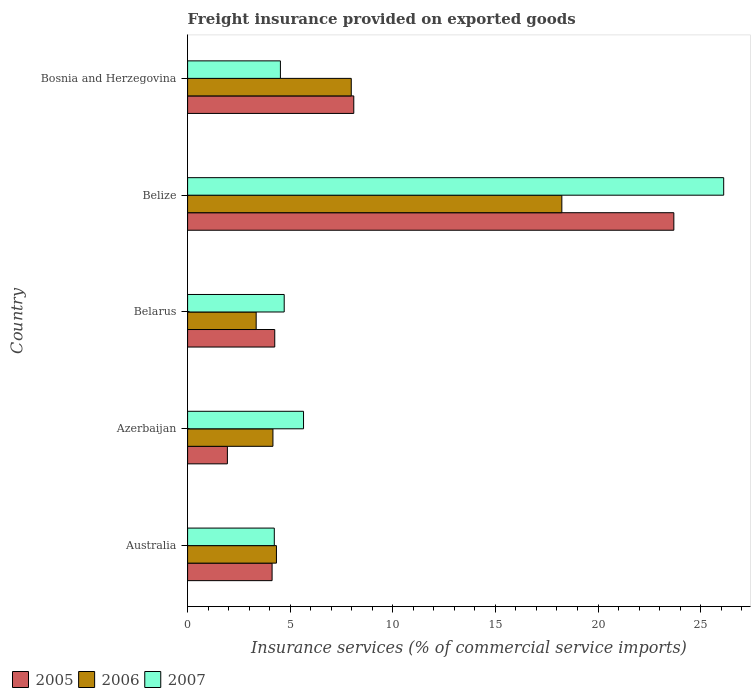How many groups of bars are there?
Your answer should be compact. 5. Are the number of bars on each tick of the Y-axis equal?
Provide a short and direct response. Yes. How many bars are there on the 1st tick from the bottom?
Your response must be concise. 3. What is the label of the 1st group of bars from the top?
Your response must be concise. Bosnia and Herzegovina. In how many cases, is the number of bars for a given country not equal to the number of legend labels?
Your answer should be very brief. 0. What is the freight insurance provided on exported goods in 2005 in Azerbaijan?
Provide a succinct answer. 1.94. Across all countries, what is the maximum freight insurance provided on exported goods in 2005?
Offer a very short reply. 23.7. Across all countries, what is the minimum freight insurance provided on exported goods in 2005?
Offer a very short reply. 1.94. In which country was the freight insurance provided on exported goods in 2005 maximum?
Your answer should be compact. Belize. What is the total freight insurance provided on exported goods in 2007 in the graph?
Your response must be concise. 45.23. What is the difference between the freight insurance provided on exported goods in 2006 in Australia and that in Belize?
Make the answer very short. -13.91. What is the difference between the freight insurance provided on exported goods in 2007 in Belize and the freight insurance provided on exported goods in 2006 in Australia?
Ensure brevity in your answer.  21.8. What is the average freight insurance provided on exported goods in 2007 per country?
Offer a terse response. 9.05. What is the difference between the freight insurance provided on exported goods in 2005 and freight insurance provided on exported goods in 2006 in Azerbaijan?
Offer a terse response. -2.22. What is the ratio of the freight insurance provided on exported goods in 2006 in Australia to that in Belize?
Your response must be concise. 0.24. Is the freight insurance provided on exported goods in 2007 in Azerbaijan less than that in Belarus?
Keep it short and to the point. No. Is the difference between the freight insurance provided on exported goods in 2005 in Australia and Azerbaijan greater than the difference between the freight insurance provided on exported goods in 2006 in Australia and Azerbaijan?
Offer a terse response. Yes. What is the difference between the highest and the second highest freight insurance provided on exported goods in 2006?
Give a very brief answer. 10.26. What is the difference between the highest and the lowest freight insurance provided on exported goods in 2006?
Your answer should be compact. 14.9. In how many countries, is the freight insurance provided on exported goods in 2006 greater than the average freight insurance provided on exported goods in 2006 taken over all countries?
Give a very brief answer. 2. How many bars are there?
Provide a short and direct response. 15. Are all the bars in the graph horizontal?
Make the answer very short. Yes. How many countries are there in the graph?
Provide a succinct answer. 5. How many legend labels are there?
Your answer should be very brief. 3. What is the title of the graph?
Provide a succinct answer. Freight insurance provided on exported goods. What is the label or title of the X-axis?
Your response must be concise. Insurance services (% of commercial service imports). What is the label or title of the Y-axis?
Provide a short and direct response. Country. What is the Insurance services (% of commercial service imports) of 2005 in Australia?
Give a very brief answer. 4.12. What is the Insurance services (% of commercial service imports) in 2006 in Australia?
Give a very brief answer. 4.33. What is the Insurance services (% of commercial service imports) of 2007 in Australia?
Keep it short and to the point. 4.23. What is the Insurance services (% of commercial service imports) in 2005 in Azerbaijan?
Provide a short and direct response. 1.94. What is the Insurance services (% of commercial service imports) in 2006 in Azerbaijan?
Your answer should be compact. 4.16. What is the Insurance services (% of commercial service imports) in 2007 in Azerbaijan?
Offer a very short reply. 5.65. What is the Insurance services (% of commercial service imports) in 2005 in Belarus?
Keep it short and to the point. 4.25. What is the Insurance services (% of commercial service imports) in 2006 in Belarus?
Make the answer very short. 3.34. What is the Insurance services (% of commercial service imports) in 2007 in Belarus?
Your answer should be very brief. 4.71. What is the Insurance services (% of commercial service imports) in 2005 in Belize?
Your answer should be compact. 23.7. What is the Insurance services (% of commercial service imports) in 2006 in Belize?
Provide a succinct answer. 18.24. What is the Insurance services (% of commercial service imports) of 2007 in Belize?
Your response must be concise. 26.13. What is the Insurance services (% of commercial service imports) in 2005 in Bosnia and Herzegovina?
Your answer should be compact. 8.1. What is the Insurance services (% of commercial service imports) of 2006 in Bosnia and Herzegovina?
Provide a succinct answer. 7.98. What is the Insurance services (% of commercial service imports) of 2007 in Bosnia and Herzegovina?
Keep it short and to the point. 4.52. Across all countries, what is the maximum Insurance services (% of commercial service imports) in 2005?
Offer a terse response. 23.7. Across all countries, what is the maximum Insurance services (% of commercial service imports) of 2006?
Ensure brevity in your answer.  18.24. Across all countries, what is the maximum Insurance services (% of commercial service imports) in 2007?
Offer a very short reply. 26.13. Across all countries, what is the minimum Insurance services (% of commercial service imports) in 2005?
Give a very brief answer. 1.94. Across all countries, what is the minimum Insurance services (% of commercial service imports) in 2006?
Your answer should be compact. 3.34. Across all countries, what is the minimum Insurance services (% of commercial service imports) in 2007?
Keep it short and to the point. 4.23. What is the total Insurance services (% of commercial service imports) of 2005 in the graph?
Ensure brevity in your answer.  42.1. What is the total Insurance services (% of commercial service imports) in 2006 in the graph?
Offer a terse response. 38.04. What is the total Insurance services (% of commercial service imports) of 2007 in the graph?
Keep it short and to the point. 45.23. What is the difference between the Insurance services (% of commercial service imports) of 2005 in Australia and that in Azerbaijan?
Your answer should be compact. 2.18. What is the difference between the Insurance services (% of commercial service imports) in 2006 in Australia and that in Azerbaijan?
Offer a terse response. 0.17. What is the difference between the Insurance services (% of commercial service imports) of 2007 in Australia and that in Azerbaijan?
Ensure brevity in your answer.  -1.42. What is the difference between the Insurance services (% of commercial service imports) of 2005 in Australia and that in Belarus?
Your answer should be very brief. -0.13. What is the difference between the Insurance services (% of commercial service imports) of 2006 in Australia and that in Belarus?
Give a very brief answer. 0.99. What is the difference between the Insurance services (% of commercial service imports) of 2007 in Australia and that in Belarus?
Make the answer very short. -0.48. What is the difference between the Insurance services (% of commercial service imports) of 2005 in Australia and that in Belize?
Your response must be concise. -19.58. What is the difference between the Insurance services (% of commercial service imports) of 2006 in Australia and that in Belize?
Give a very brief answer. -13.91. What is the difference between the Insurance services (% of commercial service imports) of 2007 in Australia and that in Belize?
Your answer should be very brief. -21.9. What is the difference between the Insurance services (% of commercial service imports) of 2005 in Australia and that in Bosnia and Herzegovina?
Ensure brevity in your answer.  -3.98. What is the difference between the Insurance services (% of commercial service imports) of 2006 in Australia and that in Bosnia and Herzegovina?
Your response must be concise. -3.65. What is the difference between the Insurance services (% of commercial service imports) of 2007 in Australia and that in Bosnia and Herzegovina?
Provide a succinct answer. -0.3. What is the difference between the Insurance services (% of commercial service imports) in 2005 in Azerbaijan and that in Belarus?
Offer a terse response. -2.31. What is the difference between the Insurance services (% of commercial service imports) in 2006 in Azerbaijan and that in Belarus?
Provide a short and direct response. 0.82. What is the difference between the Insurance services (% of commercial service imports) of 2007 in Azerbaijan and that in Belarus?
Offer a terse response. 0.94. What is the difference between the Insurance services (% of commercial service imports) in 2005 in Azerbaijan and that in Belize?
Offer a very short reply. -21.76. What is the difference between the Insurance services (% of commercial service imports) in 2006 in Azerbaijan and that in Belize?
Provide a succinct answer. -14.08. What is the difference between the Insurance services (% of commercial service imports) of 2007 in Azerbaijan and that in Belize?
Your answer should be compact. -20.47. What is the difference between the Insurance services (% of commercial service imports) of 2005 in Azerbaijan and that in Bosnia and Herzegovina?
Offer a very short reply. -6.16. What is the difference between the Insurance services (% of commercial service imports) of 2006 in Azerbaijan and that in Bosnia and Herzegovina?
Provide a succinct answer. -3.82. What is the difference between the Insurance services (% of commercial service imports) in 2007 in Azerbaijan and that in Bosnia and Herzegovina?
Make the answer very short. 1.13. What is the difference between the Insurance services (% of commercial service imports) of 2005 in Belarus and that in Belize?
Ensure brevity in your answer.  -19.45. What is the difference between the Insurance services (% of commercial service imports) in 2006 in Belarus and that in Belize?
Offer a very short reply. -14.9. What is the difference between the Insurance services (% of commercial service imports) of 2007 in Belarus and that in Belize?
Give a very brief answer. -21.42. What is the difference between the Insurance services (% of commercial service imports) in 2005 in Belarus and that in Bosnia and Herzegovina?
Your answer should be compact. -3.85. What is the difference between the Insurance services (% of commercial service imports) of 2006 in Belarus and that in Bosnia and Herzegovina?
Your response must be concise. -4.63. What is the difference between the Insurance services (% of commercial service imports) of 2007 in Belarus and that in Bosnia and Herzegovina?
Provide a succinct answer. 0.18. What is the difference between the Insurance services (% of commercial service imports) of 2005 in Belize and that in Bosnia and Herzegovina?
Provide a succinct answer. 15.6. What is the difference between the Insurance services (% of commercial service imports) in 2006 in Belize and that in Bosnia and Herzegovina?
Your response must be concise. 10.26. What is the difference between the Insurance services (% of commercial service imports) of 2007 in Belize and that in Bosnia and Herzegovina?
Provide a succinct answer. 21.6. What is the difference between the Insurance services (% of commercial service imports) of 2005 in Australia and the Insurance services (% of commercial service imports) of 2006 in Azerbaijan?
Your answer should be compact. -0.04. What is the difference between the Insurance services (% of commercial service imports) of 2005 in Australia and the Insurance services (% of commercial service imports) of 2007 in Azerbaijan?
Keep it short and to the point. -1.53. What is the difference between the Insurance services (% of commercial service imports) of 2006 in Australia and the Insurance services (% of commercial service imports) of 2007 in Azerbaijan?
Keep it short and to the point. -1.32. What is the difference between the Insurance services (% of commercial service imports) in 2005 in Australia and the Insurance services (% of commercial service imports) in 2006 in Belarus?
Provide a short and direct response. 0.78. What is the difference between the Insurance services (% of commercial service imports) in 2005 in Australia and the Insurance services (% of commercial service imports) in 2007 in Belarus?
Offer a very short reply. -0.59. What is the difference between the Insurance services (% of commercial service imports) in 2006 in Australia and the Insurance services (% of commercial service imports) in 2007 in Belarus?
Provide a succinct answer. -0.38. What is the difference between the Insurance services (% of commercial service imports) of 2005 in Australia and the Insurance services (% of commercial service imports) of 2006 in Belize?
Provide a succinct answer. -14.12. What is the difference between the Insurance services (% of commercial service imports) in 2005 in Australia and the Insurance services (% of commercial service imports) in 2007 in Belize?
Provide a succinct answer. -22.01. What is the difference between the Insurance services (% of commercial service imports) in 2006 in Australia and the Insurance services (% of commercial service imports) in 2007 in Belize?
Offer a terse response. -21.8. What is the difference between the Insurance services (% of commercial service imports) in 2005 in Australia and the Insurance services (% of commercial service imports) in 2006 in Bosnia and Herzegovina?
Provide a short and direct response. -3.86. What is the difference between the Insurance services (% of commercial service imports) in 2005 in Australia and the Insurance services (% of commercial service imports) in 2007 in Bosnia and Herzegovina?
Offer a terse response. -0.41. What is the difference between the Insurance services (% of commercial service imports) of 2006 in Australia and the Insurance services (% of commercial service imports) of 2007 in Bosnia and Herzegovina?
Provide a succinct answer. -0.19. What is the difference between the Insurance services (% of commercial service imports) of 2005 in Azerbaijan and the Insurance services (% of commercial service imports) of 2006 in Belarus?
Your answer should be very brief. -1.4. What is the difference between the Insurance services (% of commercial service imports) in 2005 in Azerbaijan and the Insurance services (% of commercial service imports) in 2007 in Belarus?
Give a very brief answer. -2.77. What is the difference between the Insurance services (% of commercial service imports) of 2006 in Azerbaijan and the Insurance services (% of commercial service imports) of 2007 in Belarus?
Your answer should be compact. -0.55. What is the difference between the Insurance services (% of commercial service imports) in 2005 in Azerbaijan and the Insurance services (% of commercial service imports) in 2006 in Belize?
Your answer should be compact. -16.3. What is the difference between the Insurance services (% of commercial service imports) of 2005 in Azerbaijan and the Insurance services (% of commercial service imports) of 2007 in Belize?
Provide a succinct answer. -24.19. What is the difference between the Insurance services (% of commercial service imports) in 2006 in Azerbaijan and the Insurance services (% of commercial service imports) in 2007 in Belize?
Ensure brevity in your answer.  -21.97. What is the difference between the Insurance services (% of commercial service imports) of 2005 in Azerbaijan and the Insurance services (% of commercial service imports) of 2006 in Bosnia and Herzegovina?
Ensure brevity in your answer.  -6.04. What is the difference between the Insurance services (% of commercial service imports) in 2005 in Azerbaijan and the Insurance services (% of commercial service imports) in 2007 in Bosnia and Herzegovina?
Give a very brief answer. -2.58. What is the difference between the Insurance services (% of commercial service imports) of 2006 in Azerbaijan and the Insurance services (% of commercial service imports) of 2007 in Bosnia and Herzegovina?
Your answer should be very brief. -0.36. What is the difference between the Insurance services (% of commercial service imports) in 2005 in Belarus and the Insurance services (% of commercial service imports) in 2006 in Belize?
Ensure brevity in your answer.  -13.99. What is the difference between the Insurance services (% of commercial service imports) of 2005 in Belarus and the Insurance services (% of commercial service imports) of 2007 in Belize?
Ensure brevity in your answer.  -21.88. What is the difference between the Insurance services (% of commercial service imports) in 2006 in Belarus and the Insurance services (% of commercial service imports) in 2007 in Belize?
Your answer should be very brief. -22.78. What is the difference between the Insurance services (% of commercial service imports) of 2005 in Belarus and the Insurance services (% of commercial service imports) of 2006 in Bosnia and Herzegovina?
Your answer should be compact. -3.73. What is the difference between the Insurance services (% of commercial service imports) of 2005 in Belarus and the Insurance services (% of commercial service imports) of 2007 in Bosnia and Herzegovina?
Ensure brevity in your answer.  -0.28. What is the difference between the Insurance services (% of commercial service imports) in 2006 in Belarus and the Insurance services (% of commercial service imports) in 2007 in Bosnia and Herzegovina?
Give a very brief answer. -1.18. What is the difference between the Insurance services (% of commercial service imports) of 2005 in Belize and the Insurance services (% of commercial service imports) of 2006 in Bosnia and Herzegovina?
Offer a terse response. 15.72. What is the difference between the Insurance services (% of commercial service imports) of 2005 in Belize and the Insurance services (% of commercial service imports) of 2007 in Bosnia and Herzegovina?
Provide a short and direct response. 19.17. What is the difference between the Insurance services (% of commercial service imports) in 2006 in Belize and the Insurance services (% of commercial service imports) in 2007 in Bosnia and Herzegovina?
Offer a terse response. 13.71. What is the average Insurance services (% of commercial service imports) of 2005 per country?
Your answer should be very brief. 8.42. What is the average Insurance services (% of commercial service imports) of 2006 per country?
Your answer should be compact. 7.61. What is the average Insurance services (% of commercial service imports) in 2007 per country?
Make the answer very short. 9.05. What is the difference between the Insurance services (% of commercial service imports) in 2005 and Insurance services (% of commercial service imports) in 2006 in Australia?
Give a very brief answer. -0.21. What is the difference between the Insurance services (% of commercial service imports) of 2005 and Insurance services (% of commercial service imports) of 2007 in Australia?
Provide a short and direct response. -0.11. What is the difference between the Insurance services (% of commercial service imports) of 2006 and Insurance services (% of commercial service imports) of 2007 in Australia?
Provide a short and direct response. 0.1. What is the difference between the Insurance services (% of commercial service imports) in 2005 and Insurance services (% of commercial service imports) in 2006 in Azerbaijan?
Your answer should be compact. -2.22. What is the difference between the Insurance services (% of commercial service imports) of 2005 and Insurance services (% of commercial service imports) of 2007 in Azerbaijan?
Provide a succinct answer. -3.71. What is the difference between the Insurance services (% of commercial service imports) in 2006 and Insurance services (% of commercial service imports) in 2007 in Azerbaijan?
Provide a succinct answer. -1.49. What is the difference between the Insurance services (% of commercial service imports) of 2005 and Insurance services (% of commercial service imports) of 2006 in Belarus?
Keep it short and to the point. 0.91. What is the difference between the Insurance services (% of commercial service imports) of 2005 and Insurance services (% of commercial service imports) of 2007 in Belarus?
Make the answer very short. -0.46. What is the difference between the Insurance services (% of commercial service imports) of 2006 and Insurance services (% of commercial service imports) of 2007 in Belarus?
Your response must be concise. -1.37. What is the difference between the Insurance services (% of commercial service imports) in 2005 and Insurance services (% of commercial service imports) in 2006 in Belize?
Make the answer very short. 5.46. What is the difference between the Insurance services (% of commercial service imports) of 2005 and Insurance services (% of commercial service imports) of 2007 in Belize?
Keep it short and to the point. -2.43. What is the difference between the Insurance services (% of commercial service imports) of 2006 and Insurance services (% of commercial service imports) of 2007 in Belize?
Provide a short and direct response. -7.89. What is the difference between the Insurance services (% of commercial service imports) of 2005 and Insurance services (% of commercial service imports) of 2006 in Bosnia and Herzegovina?
Keep it short and to the point. 0.12. What is the difference between the Insurance services (% of commercial service imports) of 2005 and Insurance services (% of commercial service imports) of 2007 in Bosnia and Herzegovina?
Your answer should be very brief. 3.58. What is the difference between the Insurance services (% of commercial service imports) of 2006 and Insurance services (% of commercial service imports) of 2007 in Bosnia and Herzegovina?
Offer a very short reply. 3.45. What is the ratio of the Insurance services (% of commercial service imports) in 2005 in Australia to that in Azerbaijan?
Provide a succinct answer. 2.12. What is the ratio of the Insurance services (% of commercial service imports) in 2006 in Australia to that in Azerbaijan?
Offer a terse response. 1.04. What is the ratio of the Insurance services (% of commercial service imports) of 2007 in Australia to that in Azerbaijan?
Ensure brevity in your answer.  0.75. What is the ratio of the Insurance services (% of commercial service imports) in 2005 in Australia to that in Belarus?
Provide a short and direct response. 0.97. What is the ratio of the Insurance services (% of commercial service imports) of 2006 in Australia to that in Belarus?
Your response must be concise. 1.3. What is the ratio of the Insurance services (% of commercial service imports) in 2007 in Australia to that in Belarus?
Offer a very short reply. 0.9. What is the ratio of the Insurance services (% of commercial service imports) in 2005 in Australia to that in Belize?
Ensure brevity in your answer.  0.17. What is the ratio of the Insurance services (% of commercial service imports) of 2006 in Australia to that in Belize?
Keep it short and to the point. 0.24. What is the ratio of the Insurance services (% of commercial service imports) in 2007 in Australia to that in Belize?
Provide a short and direct response. 0.16. What is the ratio of the Insurance services (% of commercial service imports) in 2005 in Australia to that in Bosnia and Herzegovina?
Keep it short and to the point. 0.51. What is the ratio of the Insurance services (% of commercial service imports) in 2006 in Australia to that in Bosnia and Herzegovina?
Offer a terse response. 0.54. What is the ratio of the Insurance services (% of commercial service imports) in 2007 in Australia to that in Bosnia and Herzegovina?
Provide a succinct answer. 0.93. What is the ratio of the Insurance services (% of commercial service imports) of 2005 in Azerbaijan to that in Belarus?
Offer a very short reply. 0.46. What is the ratio of the Insurance services (% of commercial service imports) in 2006 in Azerbaijan to that in Belarus?
Provide a short and direct response. 1.24. What is the ratio of the Insurance services (% of commercial service imports) in 2007 in Azerbaijan to that in Belarus?
Keep it short and to the point. 1.2. What is the ratio of the Insurance services (% of commercial service imports) in 2005 in Azerbaijan to that in Belize?
Give a very brief answer. 0.08. What is the ratio of the Insurance services (% of commercial service imports) of 2006 in Azerbaijan to that in Belize?
Offer a terse response. 0.23. What is the ratio of the Insurance services (% of commercial service imports) of 2007 in Azerbaijan to that in Belize?
Offer a very short reply. 0.22. What is the ratio of the Insurance services (% of commercial service imports) in 2005 in Azerbaijan to that in Bosnia and Herzegovina?
Your answer should be very brief. 0.24. What is the ratio of the Insurance services (% of commercial service imports) in 2006 in Azerbaijan to that in Bosnia and Herzegovina?
Your answer should be compact. 0.52. What is the ratio of the Insurance services (% of commercial service imports) of 2007 in Azerbaijan to that in Bosnia and Herzegovina?
Keep it short and to the point. 1.25. What is the ratio of the Insurance services (% of commercial service imports) in 2005 in Belarus to that in Belize?
Offer a terse response. 0.18. What is the ratio of the Insurance services (% of commercial service imports) of 2006 in Belarus to that in Belize?
Make the answer very short. 0.18. What is the ratio of the Insurance services (% of commercial service imports) in 2007 in Belarus to that in Belize?
Your answer should be compact. 0.18. What is the ratio of the Insurance services (% of commercial service imports) in 2005 in Belarus to that in Bosnia and Herzegovina?
Provide a short and direct response. 0.52. What is the ratio of the Insurance services (% of commercial service imports) of 2006 in Belarus to that in Bosnia and Herzegovina?
Ensure brevity in your answer.  0.42. What is the ratio of the Insurance services (% of commercial service imports) in 2007 in Belarus to that in Bosnia and Herzegovina?
Offer a very short reply. 1.04. What is the ratio of the Insurance services (% of commercial service imports) in 2005 in Belize to that in Bosnia and Herzegovina?
Your response must be concise. 2.93. What is the ratio of the Insurance services (% of commercial service imports) of 2006 in Belize to that in Bosnia and Herzegovina?
Your answer should be very brief. 2.29. What is the ratio of the Insurance services (% of commercial service imports) in 2007 in Belize to that in Bosnia and Herzegovina?
Offer a terse response. 5.78. What is the difference between the highest and the second highest Insurance services (% of commercial service imports) in 2005?
Make the answer very short. 15.6. What is the difference between the highest and the second highest Insurance services (% of commercial service imports) in 2006?
Provide a short and direct response. 10.26. What is the difference between the highest and the second highest Insurance services (% of commercial service imports) in 2007?
Ensure brevity in your answer.  20.47. What is the difference between the highest and the lowest Insurance services (% of commercial service imports) in 2005?
Provide a succinct answer. 21.76. What is the difference between the highest and the lowest Insurance services (% of commercial service imports) in 2006?
Your answer should be compact. 14.9. What is the difference between the highest and the lowest Insurance services (% of commercial service imports) of 2007?
Offer a very short reply. 21.9. 